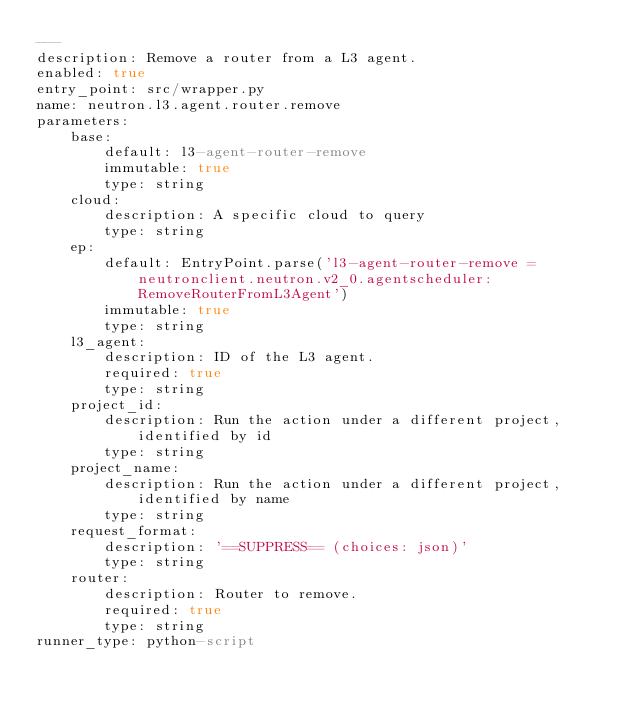<code> <loc_0><loc_0><loc_500><loc_500><_YAML_>---
description: Remove a router from a L3 agent.
enabled: true
entry_point: src/wrapper.py
name: neutron.l3.agent.router.remove
parameters:
    base:
        default: l3-agent-router-remove
        immutable: true
        type: string
    cloud:
        description: A specific cloud to query
        type: string
    ep:
        default: EntryPoint.parse('l3-agent-router-remove = neutronclient.neutron.v2_0.agentscheduler:RemoveRouterFromL3Agent')
        immutable: true
        type: string
    l3_agent:
        description: ID of the L3 agent.
        required: true
        type: string
    project_id:
        description: Run the action under a different project, identified by id
        type: string
    project_name:
        description: Run the action under a different project, identified by name
        type: string
    request_format:
        description: '==SUPPRESS== (choices: json)'
        type: string
    router:
        description: Router to remove.
        required: true
        type: string
runner_type: python-script
</code> 